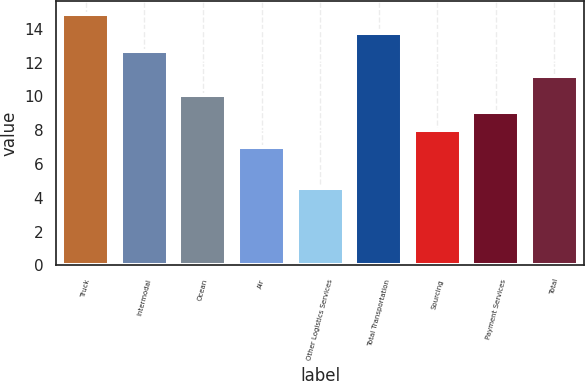Convert chart to OTSL. <chart><loc_0><loc_0><loc_500><loc_500><bar_chart><fcel>Truck<fcel>Intermodal<fcel>Ocean<fcel>Air<fcel>Other Logistics Services<fcel>Total Transportation<fcel>Sourcing<fcel>Payment Services<fcel>Total<nl><fcel>14.9<fcel>12.7<fcel>10.1<fcel>7<fcel>4.6<fcel>13.73<fcel>8.03<fcel>9.06<fcel>11.2<nl></chart> 